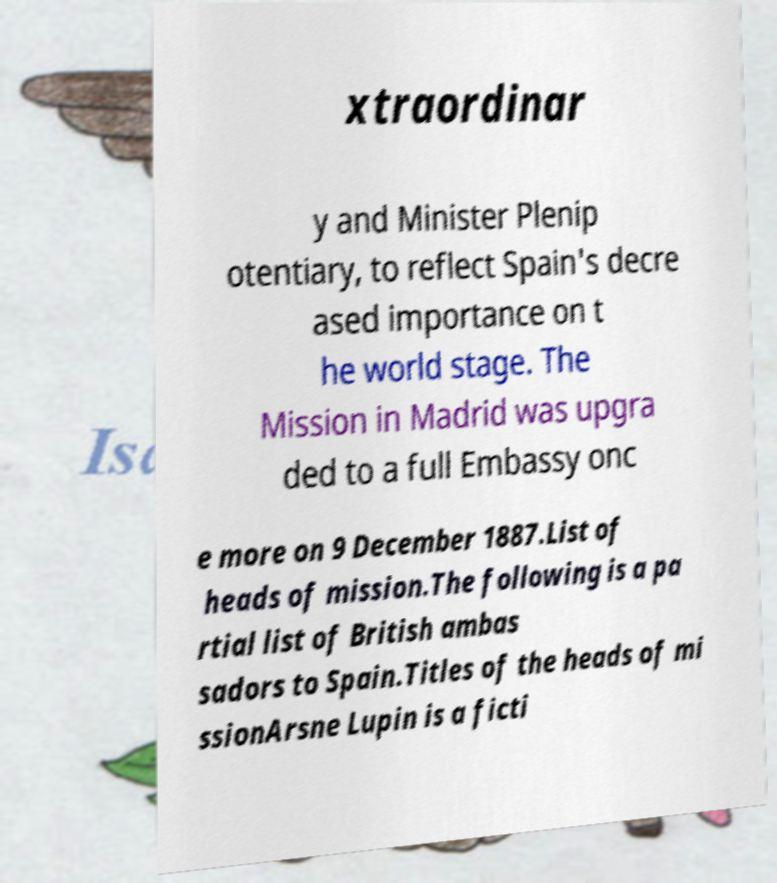There's text embedded in this image that I need extracted. Can you transcribe it verbatim? xtraordinar y and Minister Plenip otentiary, to reflect Spain's decre ased importance on t he world stage. The Mission in Madrid was upgra ded to a full Embassy onc e more on 9 December 1887.List of heads of mission.The following is a pa rtial list of British ambas sadors to Spain.Titles of the heads of mi ssionArsne Lupin is a ficti 